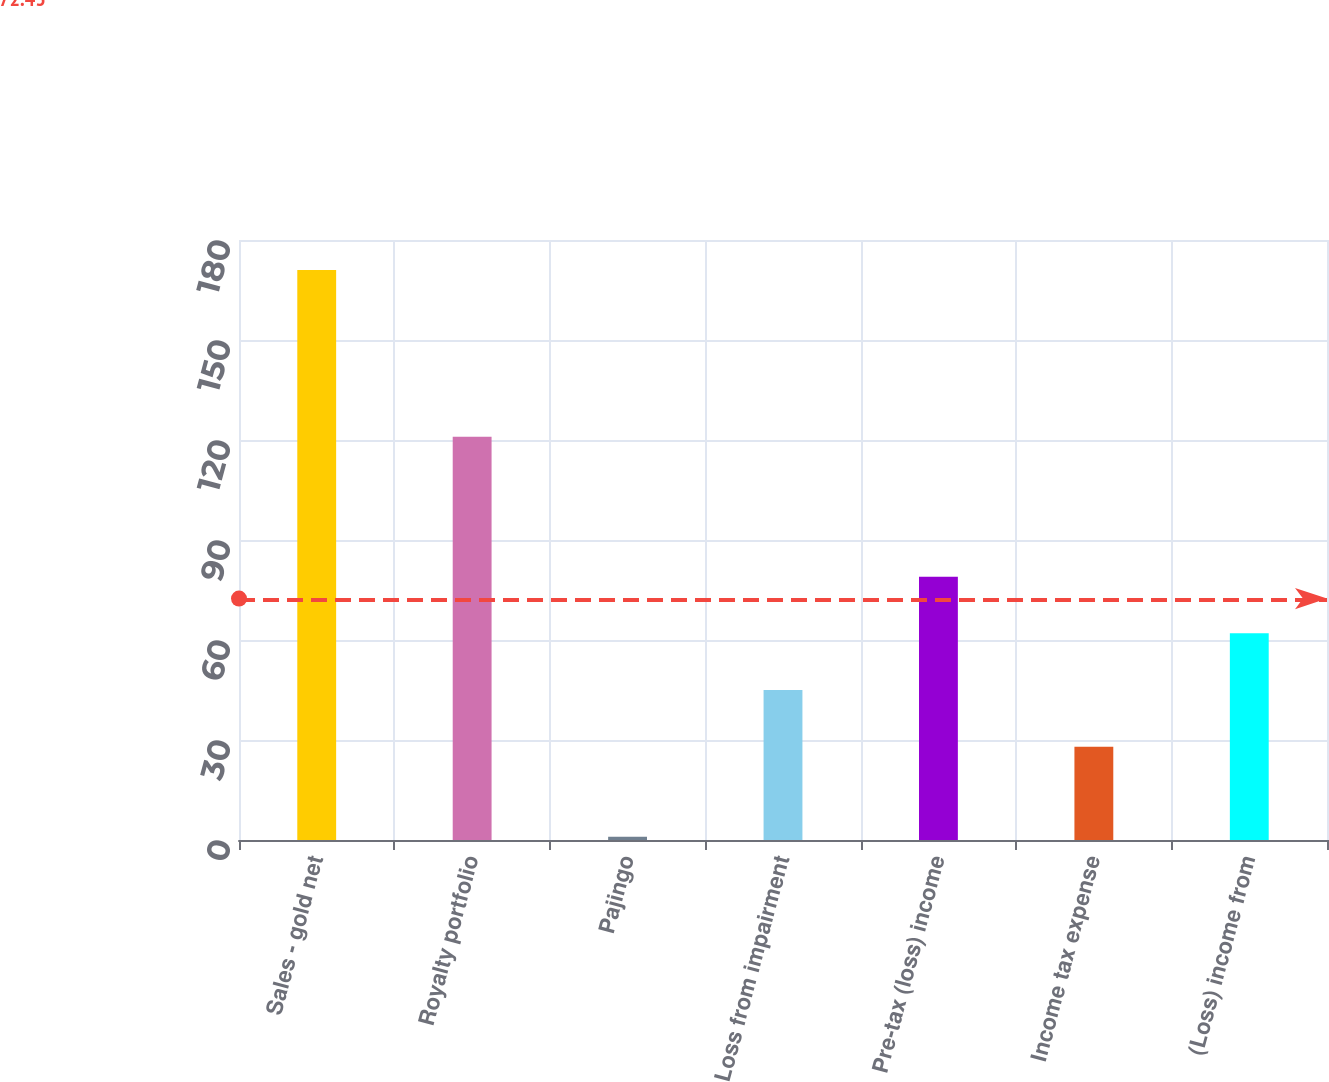Convert chart to OTSL. <chart><loc_0><loc_0><loc_500><loc_500><bar_chart><fcel>Sales - gold net<fcel>Royalty portfolio<fcel>Pajingo<fcel>Loss from impairment<fcel>Pre-tax (loss) income<fcel>Income tax expense<fcel>(Loss) income from<nl><fcel>171<fcel>121<fcel>1<fcel>45<fcel>79<fcel>28<fcel>62<nl></chart> 